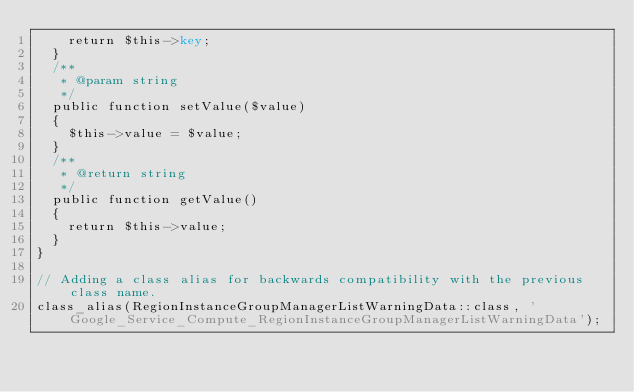Convert code to text. <code><loc_0><loc_0><loc_500><loc_500><_PHP_>    return $this->key;
  }
  /**
   * @param string
   */
  public function setValue($value)
  {
    $this->value = $value;
  }
  /**
   * @return string
   */
  public function getValue()
  {
    return $this->value;
  }
}

// Adding a class alias for backwards compatibility with the previous class name.
class_alias(RegionInstanceGroupManagerListWarningData::class, 'Google_Service_Compute_RegionInstanceGroupManagerListWarningData');
</code> 